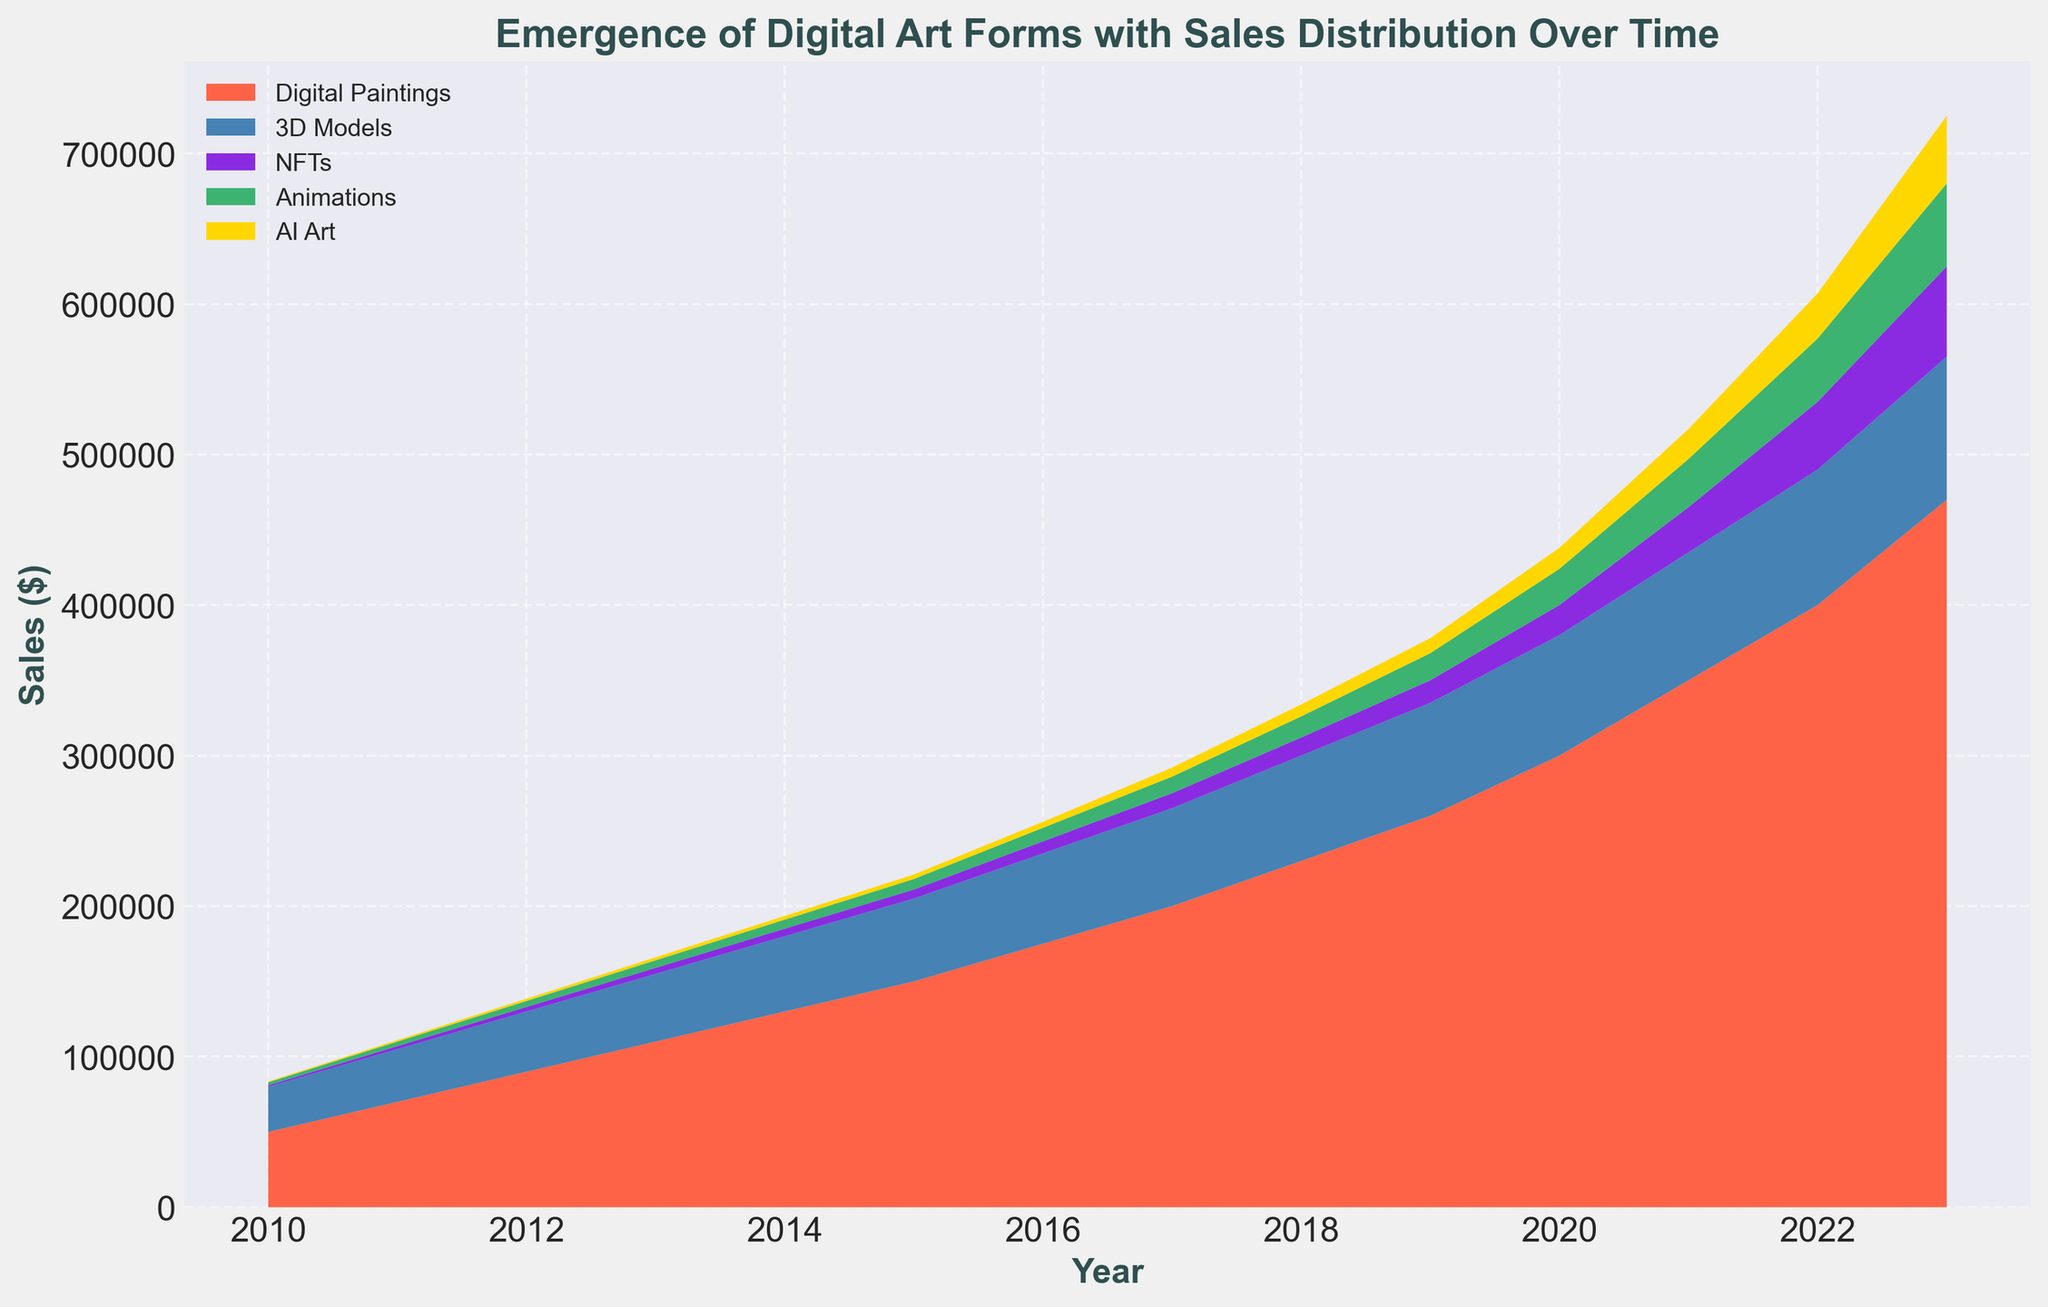What is the trend for the sales of AI Art from 2010 to 2023? The sales of AI Art show a consistent increasing trend over the years. Initially, sales were as low as $500 in 2010, and they increased steadily, reaching up to $45,000 in 2023.
Answer: Increasing Which year saw the highest combined sales for Digital Paintings and NFTs? To find the highest combined sales year, we need to sum the sales of Digital Paintings and NFTs for each year and compare them. In 2023, the combined sales of Digital Paintings ($470,000) and NFTs ($60,000) total $530,000, which is the highest.
Answer: 2023 How do the sales of 3D Models compare to the sales of Animations in 2022? In 2022, the sales of 3D Models are $90,000, while the sales of Animations are $42,000. By comparing the two, we can see that the sales of 3D Models are higher than those of Animations by $48,000.
Answer: 3D Models are higher By how much did the sales of NFTs increase from 2020 to 2023? Sales of NFTs in 2020 were $20,000. In 2023, they increased to $60,000. The difference between the two is $60,000 - $20,000 = $40,000.
Answer: $40,000 Which art form had the lowest sales in 2015 and what was the value? By inspecting the sales figures for 2015, AI Art had the lowest sales with a value of $3,000.
Answer: AI Art, $3,000 What is the overall growth in sales for Digital Paintings from 2010 to 2023? Digital Paintings sales in 2010 were $50,000 and grew to $470,000 in 2023. The overall growth is $470,000 - $50,000 = $420,000.
Answer: $420,000 Compare the combined sales of Animations and AI Art in 2020 to the combined sales of these two categories in 2023. In 2020, Animations had sales of $24,000 and AI Art had $14,000, making a total of $38,000. In 2023, Animations had $55,000 and AI Art had $45,000, totaling $100,000. The combined sales increased by $100,000 - $38,000 = $62,000.
Answer: Increased by $62,000 Describe the coloration pattern used in the area chart for different digital art forms. The colors used for the different art forms are as follows: Digital Paintings (red), 3D Models (blue), NFTs (purple), Animations (green), and AI Art (yellow). These distinct colors help in visually differentiating the data over time.
Answer: Red, Blue, Purple, Green, Yellow What is the trend of the sales of NFTs compared to the trend of Digital Paintings between 2018 and 2023? Both NFTs and Digital Paintings show an increasing trend from 2018 to 2023. However, the rate of increase for NFTs is more rapid compared to Digital Paintings.
Answer: Increasing, NFTs more rapidly 